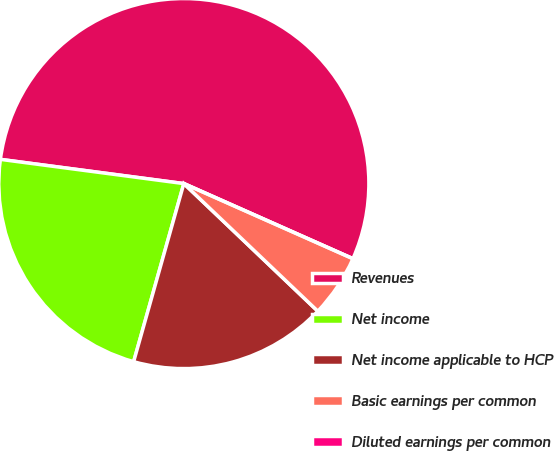<chart> <loc_0><loc_0><loc_500><loc_500><pie_chart><fcel>Revenues<fcel>Net income<fcel>Net income applicable to HCP<fcel>Basic earnings per common<fcel>Diluted earnings per common<nl><fcel>54.57%<fcel>22.72%<fcel>17.26%<fcel>5.46%<fcel>0.0%<nl></chart> 